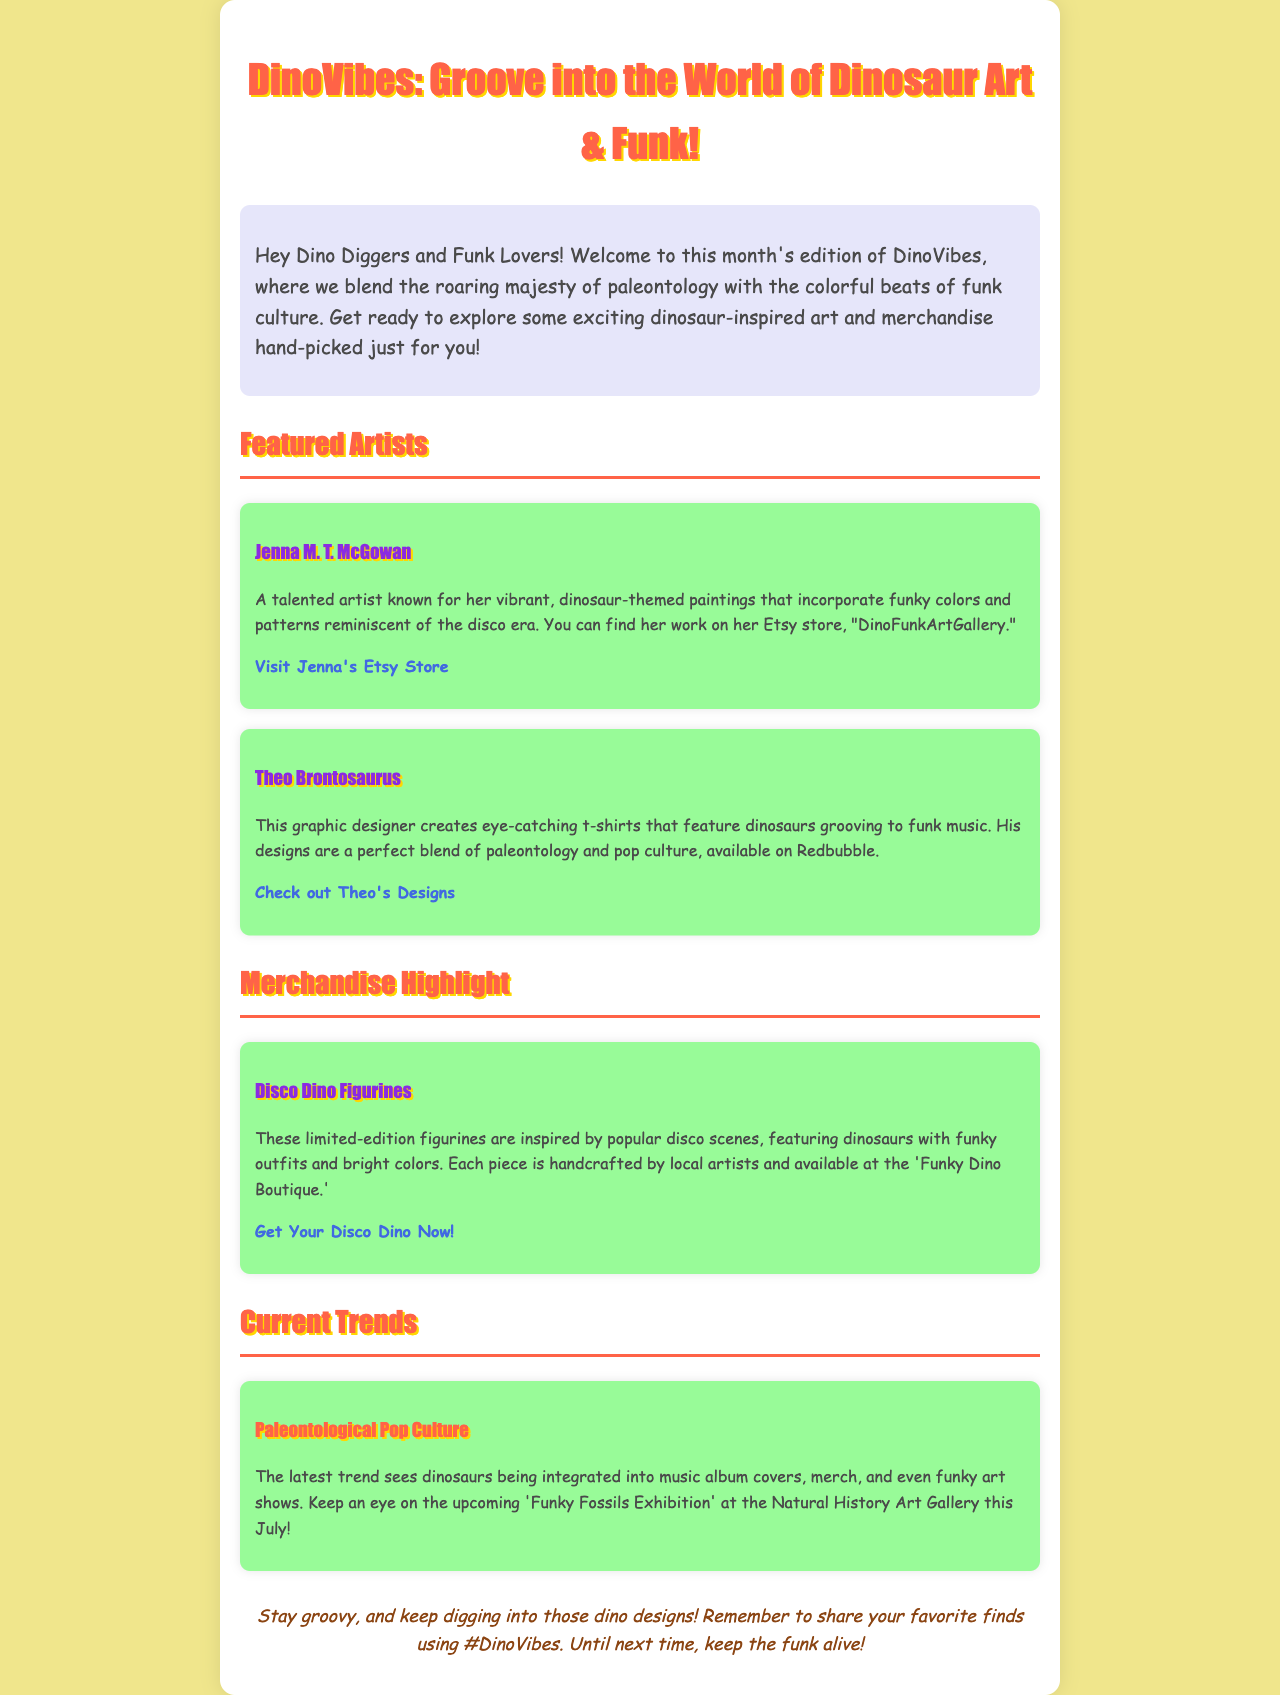What is the title of the newsletter? The title "DinoVibes: Groove into the World of Dinosaur Art & Funk!" is mentioned at the top of the document.
Answer: DinoVibes: Groove into the World of Dinosaur Art & Funk! Who is the featured artist known for vibrant dinosaur-themed paintings? Jenna M. T. McGowan is identified as the artist known for her vibrant, dinosaur-themed paintings.
Answer: Jenna M. T. McGowan What does Theo Brontosaurus design? Theo Brontosaurus creates eye-catching t-shirts featuring dinosaurs grooving to funk music.
Answer: T-shirts What are the Disco Dino Figurines inspired by? The Disco Dino Figurines are inspired by popular disco scenes.
Answer: Popular disco scenes What is the latest trend mentioned in the newsletter? The latest trend mentioned is "Paleontological Pop Culture," integrating dinosaurs into various media.
Answer: Paleontological Pop Culture Where can you purchase Jenna's art? Jenna's art can be purchased on her Etsy store, "DinoFunkArtGallery."
Answer: Etsy store What event is mentioned to occur in July? The document mentions the upcoming 'Funky Fossils Exhibition' at the Natural History Art Gallery in July.
Answer: Funky Fossils Exhibition What hashtag should you use to share favorite finds? The hashtag to share favorite finds is #DinoVibes.
Answer: #DinoVibes 